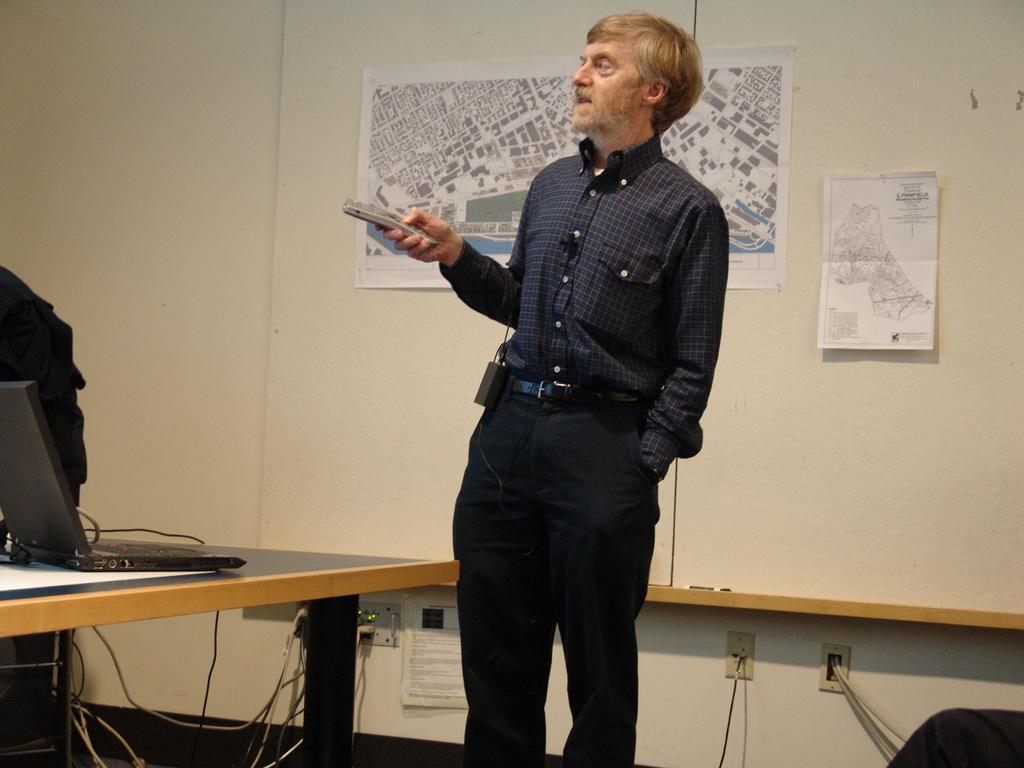In one or two sentences, can you explain what this image depicts? In this picture A Man Standing, and he is holding a remote in his hand, in front of him we can find a laptop on the table, and also we can find couple of cables under the table, and we can see a map on the wall. 